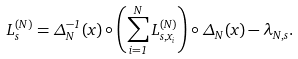Convert formula to latex. <formula><loc_0><loc_0><loc_500><loc_500>L _ { s } ^ { ( N ) } = \Delta ^ { - 1 } _ { N } ( x ) \circ \left ( \sum _ { i = 1 } ^ { N } L ^ { ( N ) } _ { s , x _ { i } } \right ) \circ \Delta _ { N } ( x ) - \lambda _ { N , s } .</formula> 